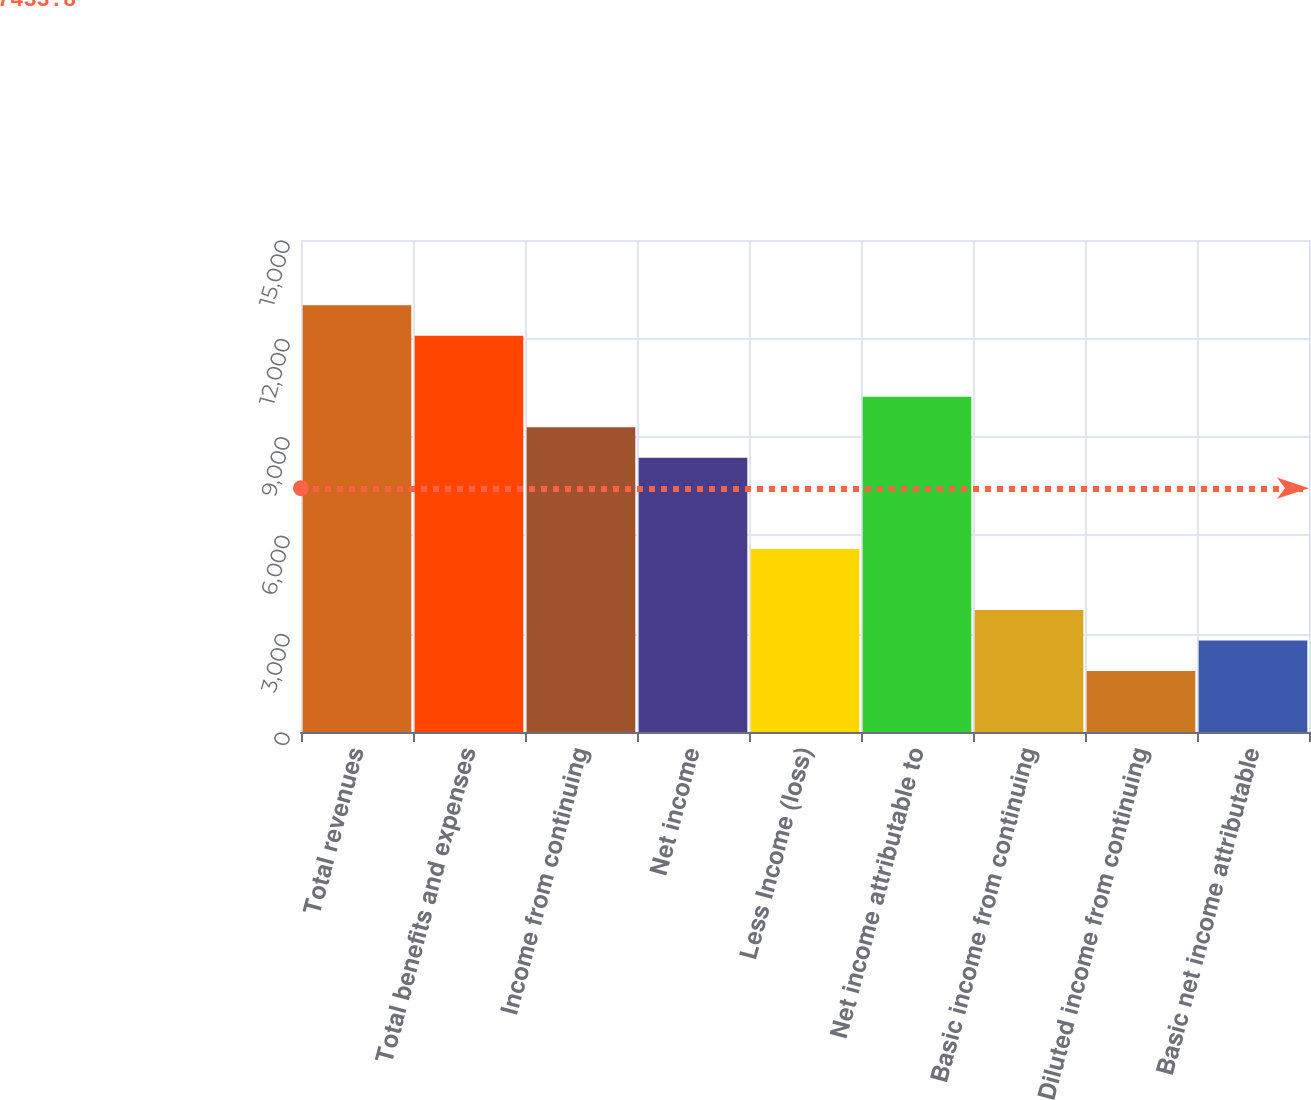Convert chart to OTSL. <chart><loc_0><loc_0><loc_500><loc_500><bar_chart><fcel>Total revenues<fcel>Total benefits and expenses<fcel>Income from continuing<fcel>Net income<fcel>Less Income (loss)<fcel>Net income attributable to<fcel>Basic income from continuing<fcel>Diluted income from continuing<fcel>Basic net income attributable<nl><fcel>13008.4<fcel>12079.3<fcel>9292<fcel>8362.9<fcel>5575.6<fcel>10221.1<fcel>3717.4<fcel>1859.2<fcel>2788.3<nl></chart> 